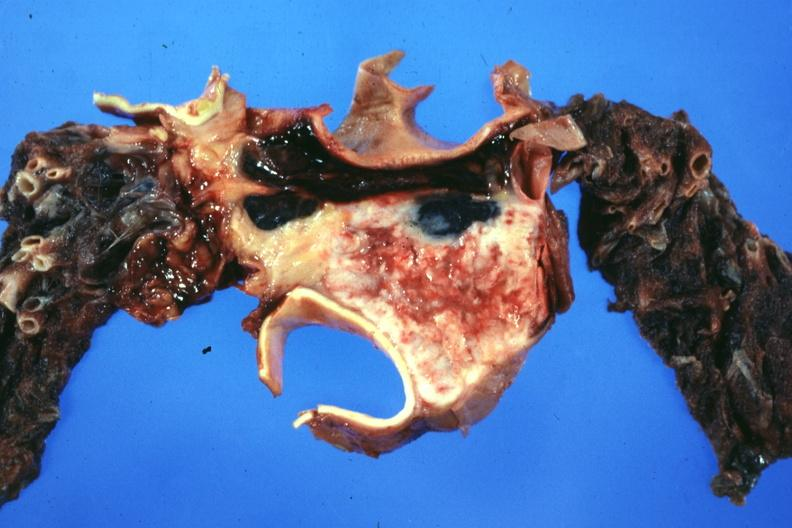s malignant thymoma present?
Answer the question using a single word or phrase. Yes 